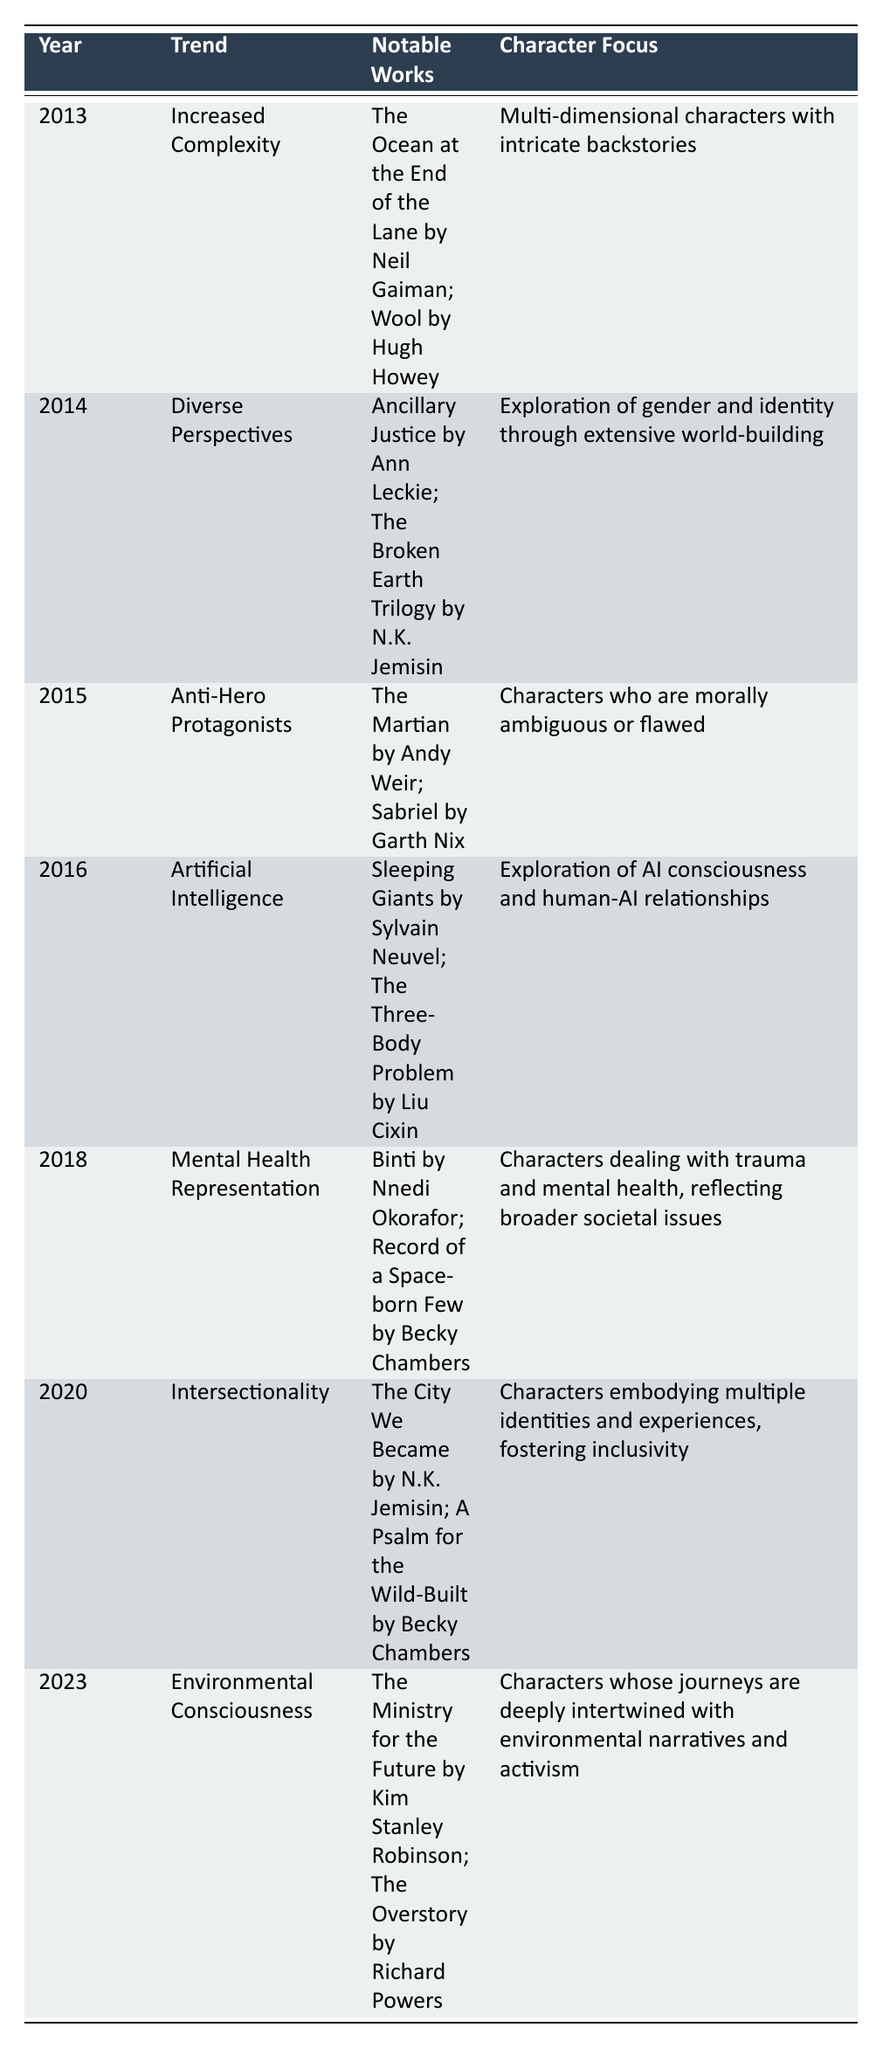What trend was noted in 2016? Referring to the table, the trend in 2016 is listed as "Artificial Intelligence."
Answer: Artificial Intelligence Which notable work from 2018 emphasizes mental health representation? Looking at the table, one of the notable works from 2018 is "Binti by Nnedi Okorafor," which focuses on mental health representation.
Answer: Binti by Nnedi Okorafor How many trends mentioned in the table focus on AI or related themes? The table shows one trend for 2016, titled "Artificial Intelligence," which explores AI consciousness and human-AI relationships. No other trend explicitly focuses on AI, so the total is one.
Answer: 1 Is "The Broken Earth Trilogy by N.K. Jemisin" related to intersectionality? According to the table, "The Broken Earth Trilogy" is noted under the 2014 trend of "Diverse Perspectives," but there is no mention of it being related to intersectionality. Thus, the answer is no.
Answer: No What character focus was prevalent in the year 2020? For 2020, the character focus noted in the table is "Characters embodying multiple identities and experiences, fostering inclusivity."
Answer: Multiple identities and experiences In which year did the trend shift towards environmental consciousness? By consulting the table, it is clear that the trend towards environmental consciousness occurred in 2023.
Answer: 2023 Compare the trends from 2013 to 2023: How many different character focus areas are represented? From the table, we identify unique character focus areas for each selected year: 2013 - multi-dimensional characters; 2014 - exploration of gender and identity; 2015 - morally ambiguous characters; 2016 - AI consciousness; 2018 - mental health; 2020 - inclusivity; and 2023 - environmental narratives. Therefore, there are a total of six distinct character focus areas across the years.
Answer: 6 Is the character focus in 2015 related to trauma? The character focus in 2015 is listed as "Characters who are morally ambiguous or flawed." Since trauma is not mentioned here, the answer to whether it is related to trauma is no.
Answer: No What trend appears to have the richest character development focus according to the information from 2014? The 2014 trend, "Diverse Perspectives," emphasizes extensive world-building and exploration of gender and identity. This suggests a rich character development focus as it delves deeply into personal and social dimensions.
Answer: Diverse Perspectives 